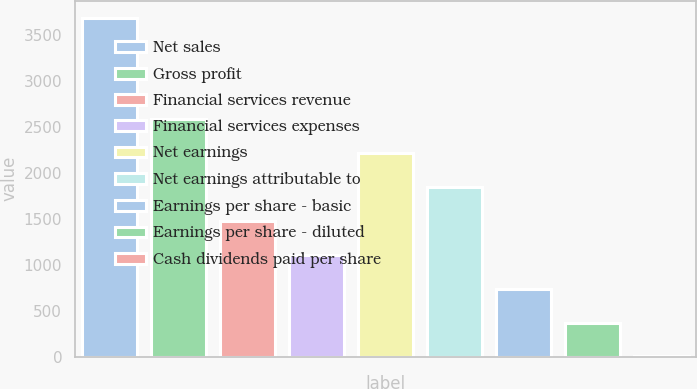<chart> <loc_0><loc_0><loc_500><loc_500><bar_chart><fcel>Net sales<fcel>Gross profit<fcel>Financial services revenue<fcel>Financial services expenses<fcel>Net earnings<fcel>Net earnings attributable to<fcel>Earnings per share - basic<fcel>Earnings per share - diluted<fcel>Cash dividends paid per share<nl><fcel>3686.9<fcel>2581.72<fcel>1476.54<fcel>1108.14<fcel>2213.33<fcel>1844.93<fcel>739.75<fcel>371.35<fcel>2.95<nl></chart> 